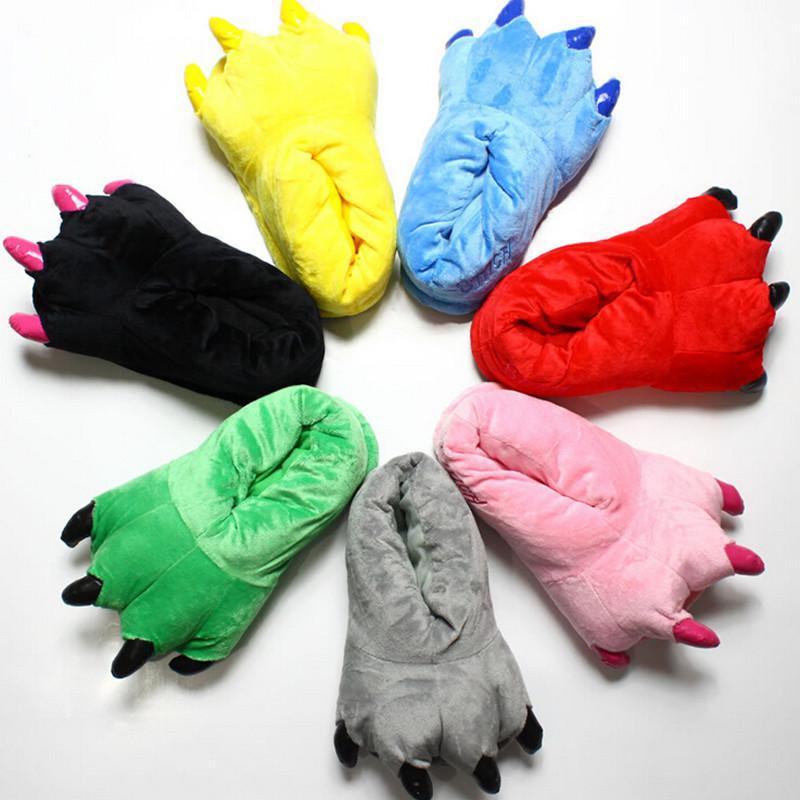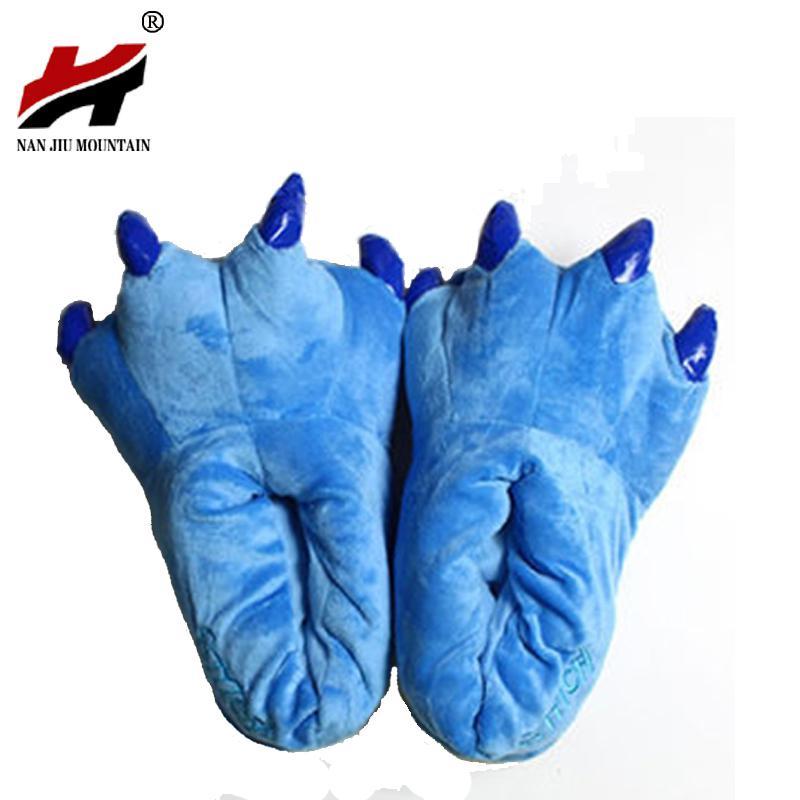The first image is the image on the left, the second image is the image on the right. Evaluate the accuracy of this statement regarding the images: "Three or more slippers in two or more colors resemble animal feet, with plastic toenails protruding from the end of each slipper.". Is it true? Answer yes or no. Yes. The first image is the image on the left, the second image is the image on the right. For the images displayed, is the sentence "All slippers are solid colors and have four claws that project outward, but only the right image shows a matched pair of slippers." factually correct? Answer yes or no. Yes. 